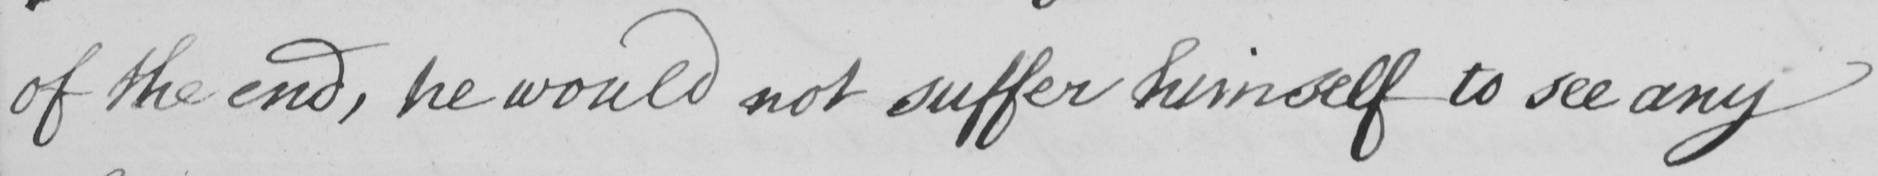Transcribe the text shown in this historical manuscript line. of the end , he would not suffer himself to see any 